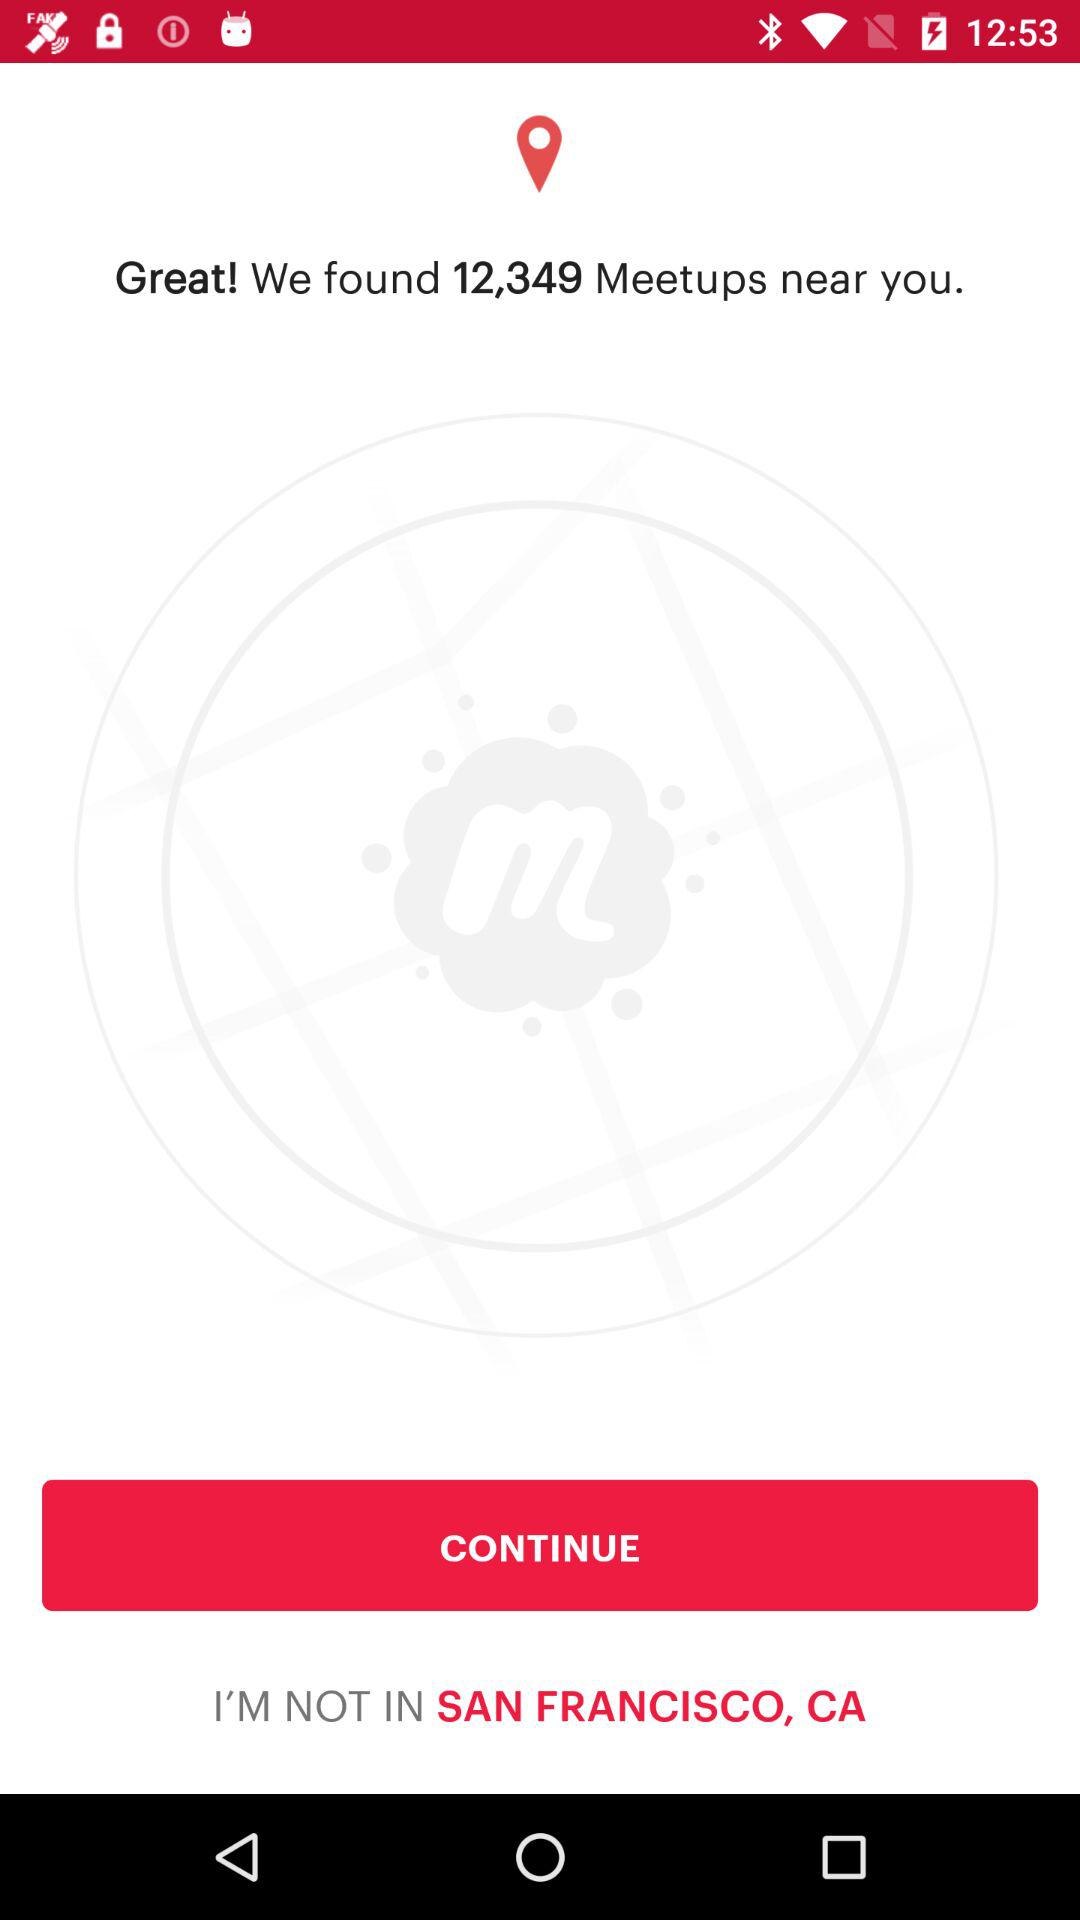How many meetups do we have? You have 12,349 meetups. 